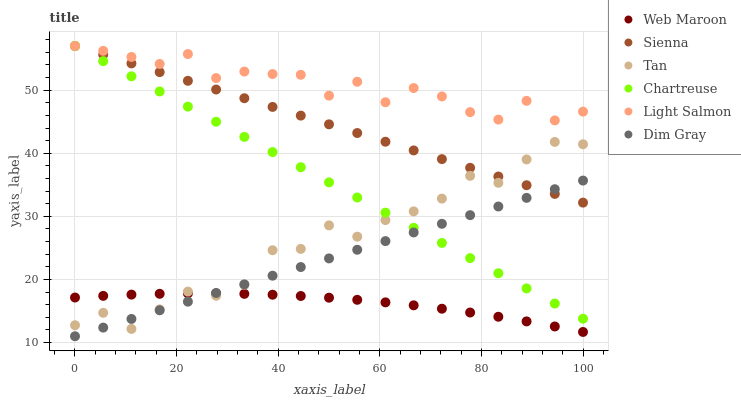Does Web Maroon have the minimum area under the curve?
Answer yes or no. Yes. Does Light Salmon have the maximum area under the curve?
Answer yes or no. Yes. Does Dim Gray have the minimum area under the curve?
Answer yes or no. No. Does Dim Gray have the maximum area under the curve?
Answer yes or no. No. Is Dim Gray the smoothest?
Answer yes or no. Yes. Is Tan the roughest?
Answer yes or no. Yes. Is Web Maroon the smoothest?
Answer yes or no. No. Is Web Maroon the roughest?
Answer yes or no. No. Does Dim Gray have the lowest value?
Answer yes or no. Yes. Does Web Maroon have the lowest value?
Answer yes or no. No. Does Chartreuse have the highest value?
Answer yes or no. Yes. Does Dim Gray have the highest value?
Answer yes or no. No. Is Dim Gray less than Light Salmon?
Answer yes or no. Yes. Is Chartreuse greater than Web Maroon?
Answer yes or no. Yes. Does Chartreuse intersect Sienna?
Answer yes or no. Yes. Is Chartreuse less than Sienna?
Answer yes or no. No. Is Chartreuse greater than Sienna?
Answer yes or no. No. Does Dim Gray intersect Light Salmon?
Answer yes or no. No. 